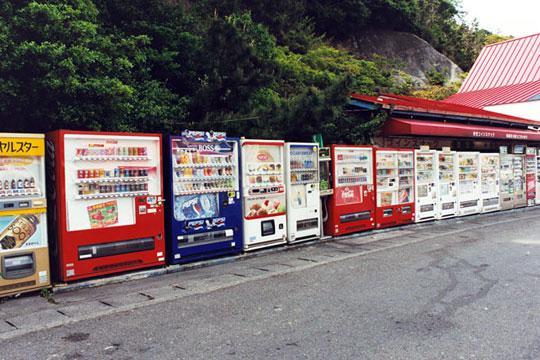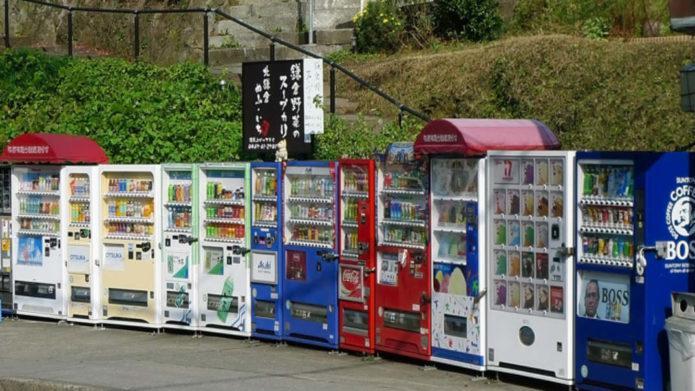The first image is the image on the left, the second image is the image on the right. Analyze the images presented: Is the assertion "Red canapes cover some of the machines outside." valid? Answer yes or no. Yes. The first image is the image on the left, the second image is the image on the right. Evaluate the accuracy of this statement regarding the images: "Each image depicts a long row of outdoor red, white, and blue vending machines parked in front of a green area, with pavement in front.". Is it true? Answer yes or no. Yes. 